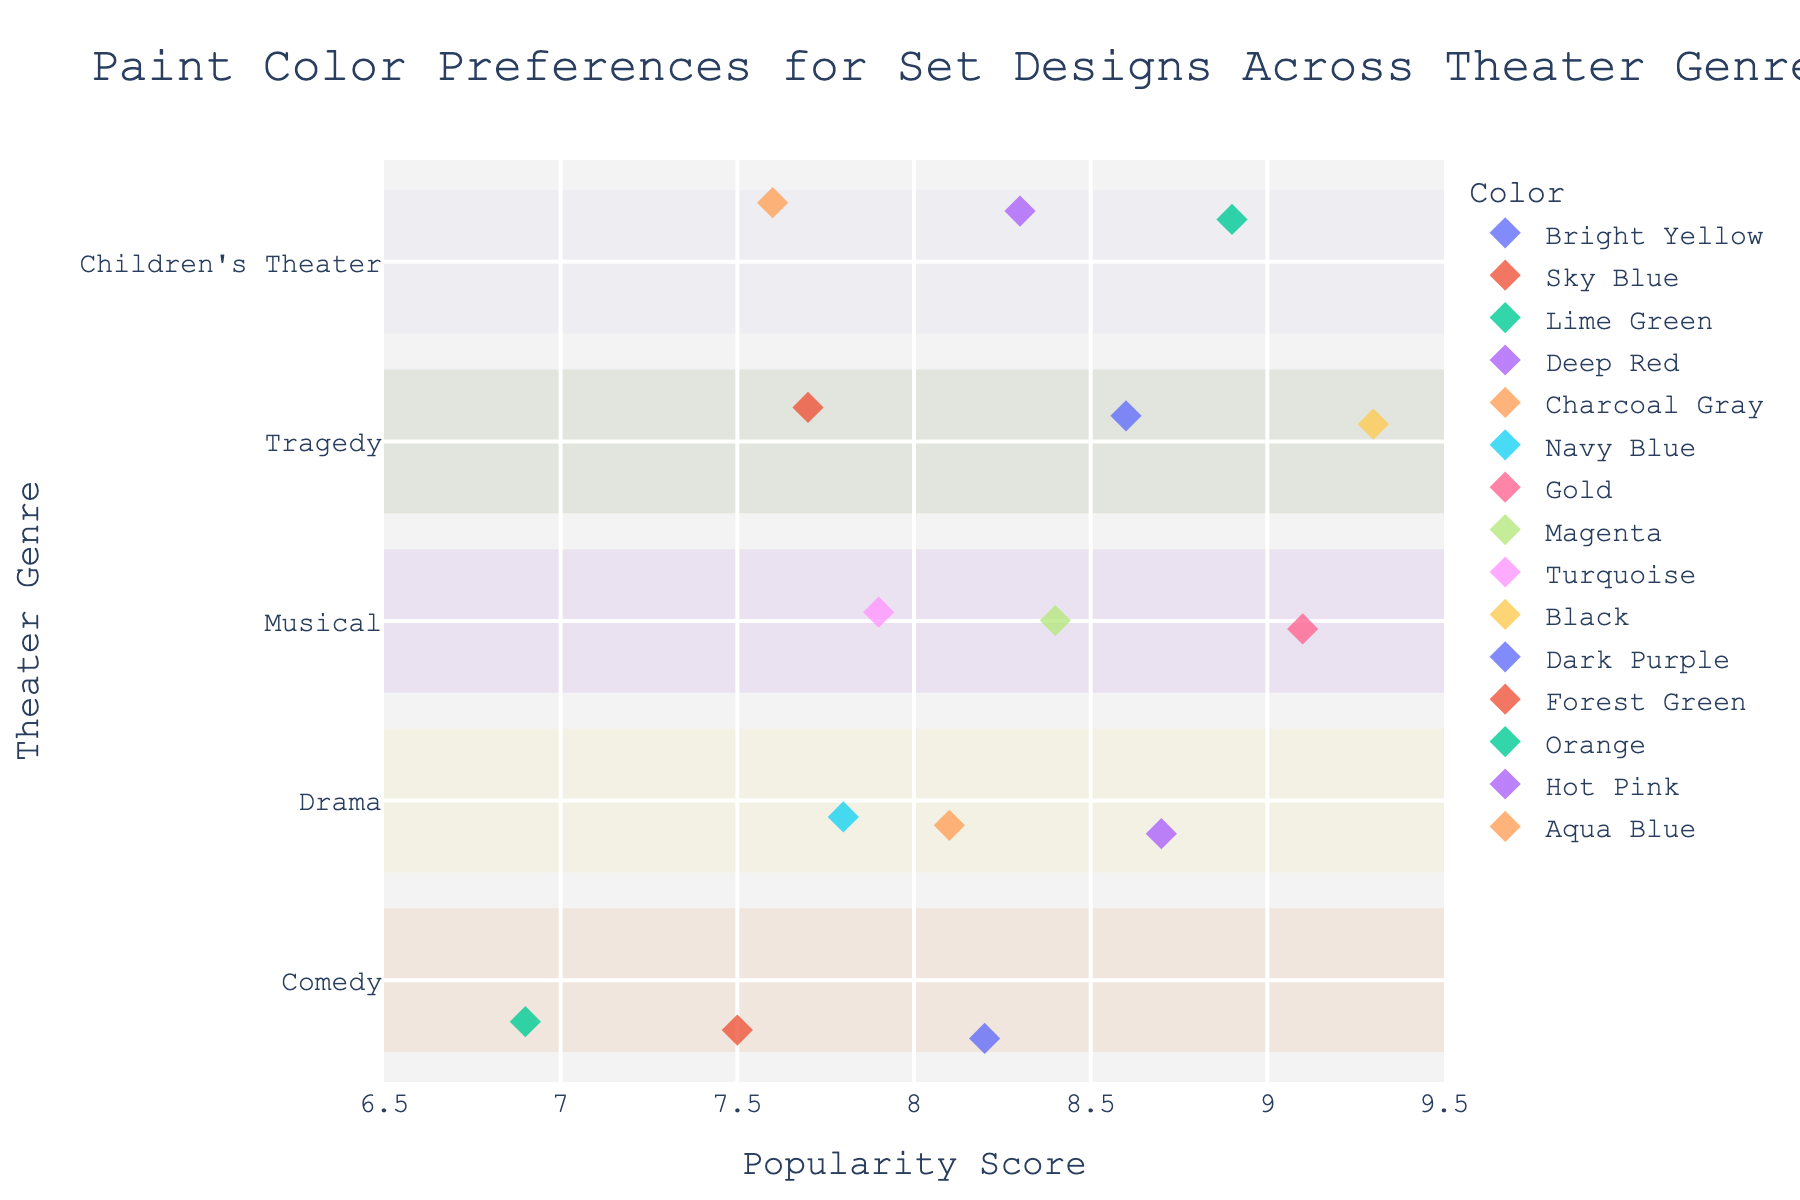What is the most popular paint color for Tragedy sets? Look for the highest popularity score within the "Tragedy" genre. The color with a score of 9.3 is Black.
Answer: Black How many paint colors have a popularity score above 8.5 in Children's Theater? Count the points corresponding to Children's Theater with popularity scores above 8.5. Orange and Hot Pink have scores of 8.9 and 8.3, respectively.
Answer: 1 (Orange) Which genre has the highest average popularity score? Calculate the average popularity score for each genre and compare them. Comedy: (8.2 + 7.5 + 6.9)/3 = 7.53, Drama: (8.7 + 8.1 + 7.8)/3 = 8.2, Musical: (9.1 + 8.4 + 7.9)/3 = 8.47, Tragedy: (9.3 + 8.6 + 7.7)/3 = 8.53, Children's Theater: (8.9 + 8.3 + 7.6)/3 = 8.27.
Answer: Tragedy Are Navy Blue and Charcoal Gray equally popular in Drama? Compare the popularity scores of Navy Blue and Charcoal Gray under the Drama genre. Navy Blue has a score of 7.8 while Charcoal Gray has 8.1.
Answer: No Which color is least popular among Comedy set designs? Identify the color with the lowest popularity score within the "Comedy" genre. Lime Green has a score of 6.9.
Answer: Lime Green 